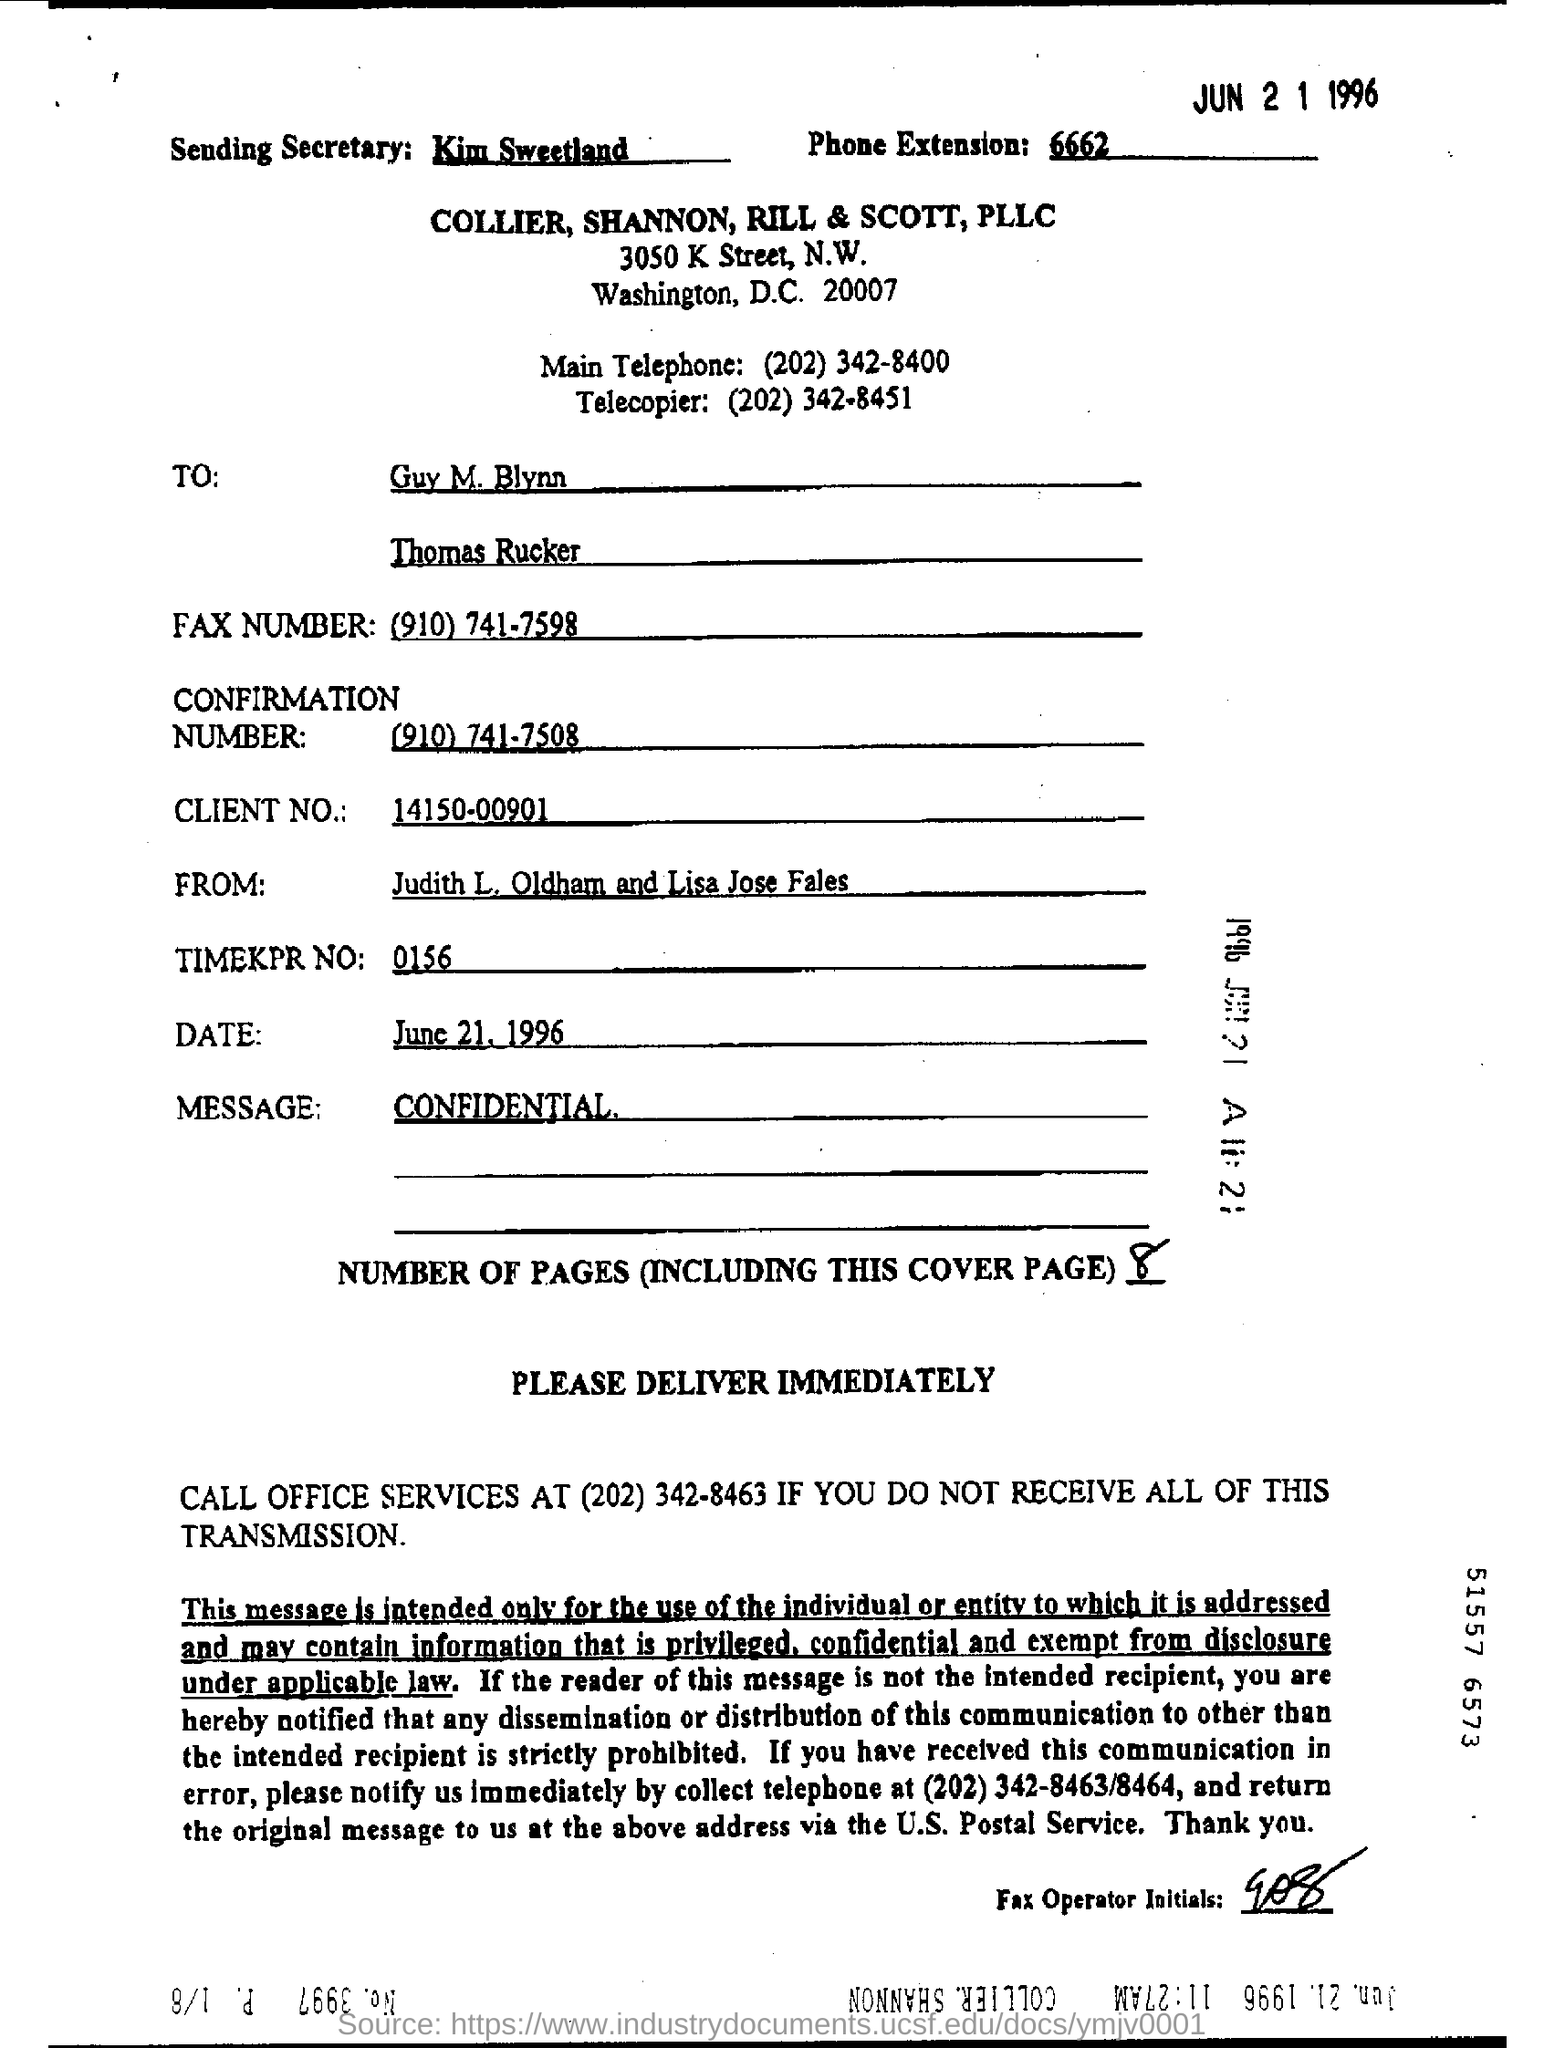Highlight a few significant elements in this photo. The individual is seeking confirmation of a number and provided their contact information, including a phone number with a prefix of "910" and a suffix of "7508" at the end of the call. The sending secretary is Kim Sweetland. The fax number is (910) 741-7508. The phone extension given in the form is 6662... The client number mentioned in the form is 14150-00901. 